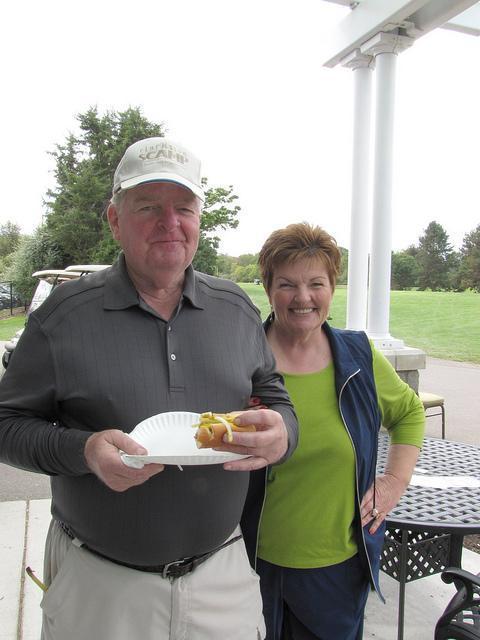How many people are there?
Give a very brief answer. 2. How many dining tables are there?
Give a very brief answer. 1. 